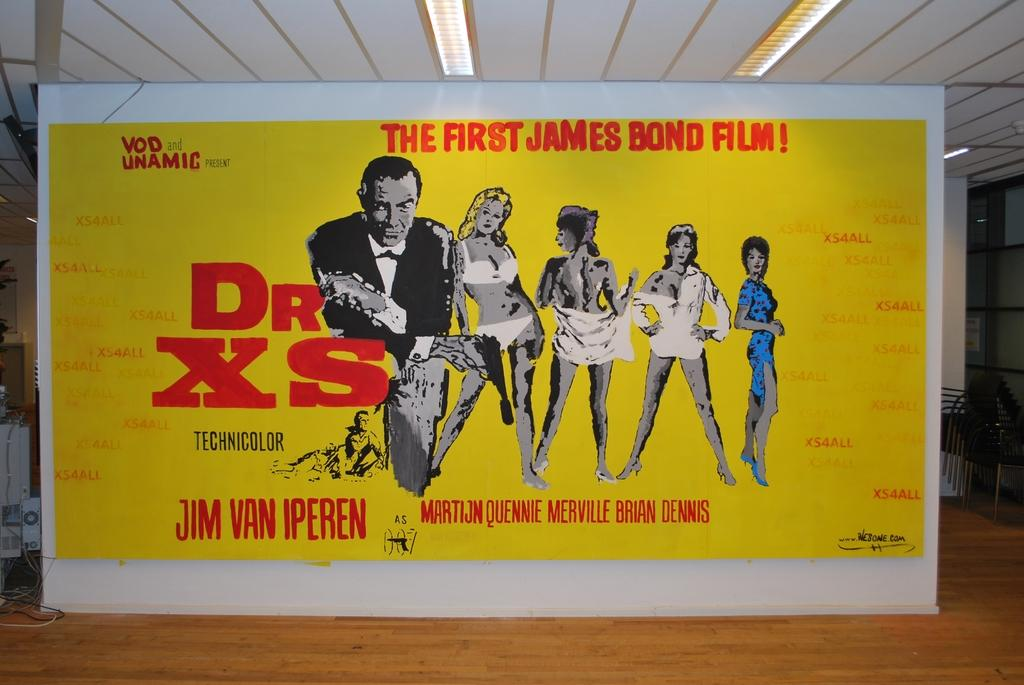<image>
Share a concise interpretation of the image provided. A poster in yellow advertising 'The First James Bond Film!' 